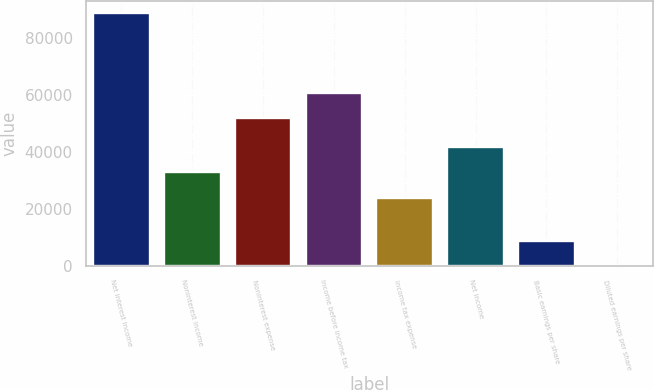Convert chart to OTSL. <chart><loc_0><loc_0><loc_500><loc_500><bar_chart><fcel>Net interest income<fcel>Noninterest income<fcel>Noninterest expense<fcel>Income before income tax<fcel>Income tax expense<fcel>Net income<fcel>Basic earnings per share<fcel>Diluted earnings per share<nl><fcel>88684<fcel>32796.3<fcel>51818<fcel>60686.3<fcel>23928<fcel>41664.7<fcel>8869.03<fcel>0.7<nl></chart> 